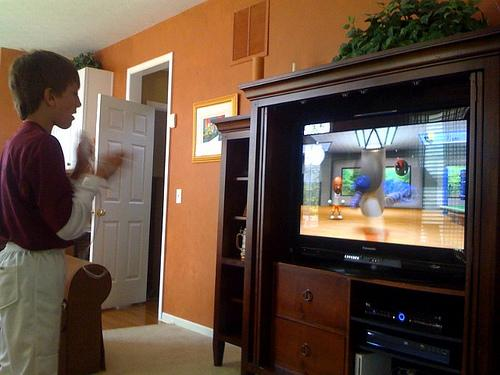What is the person engaged in? video game 